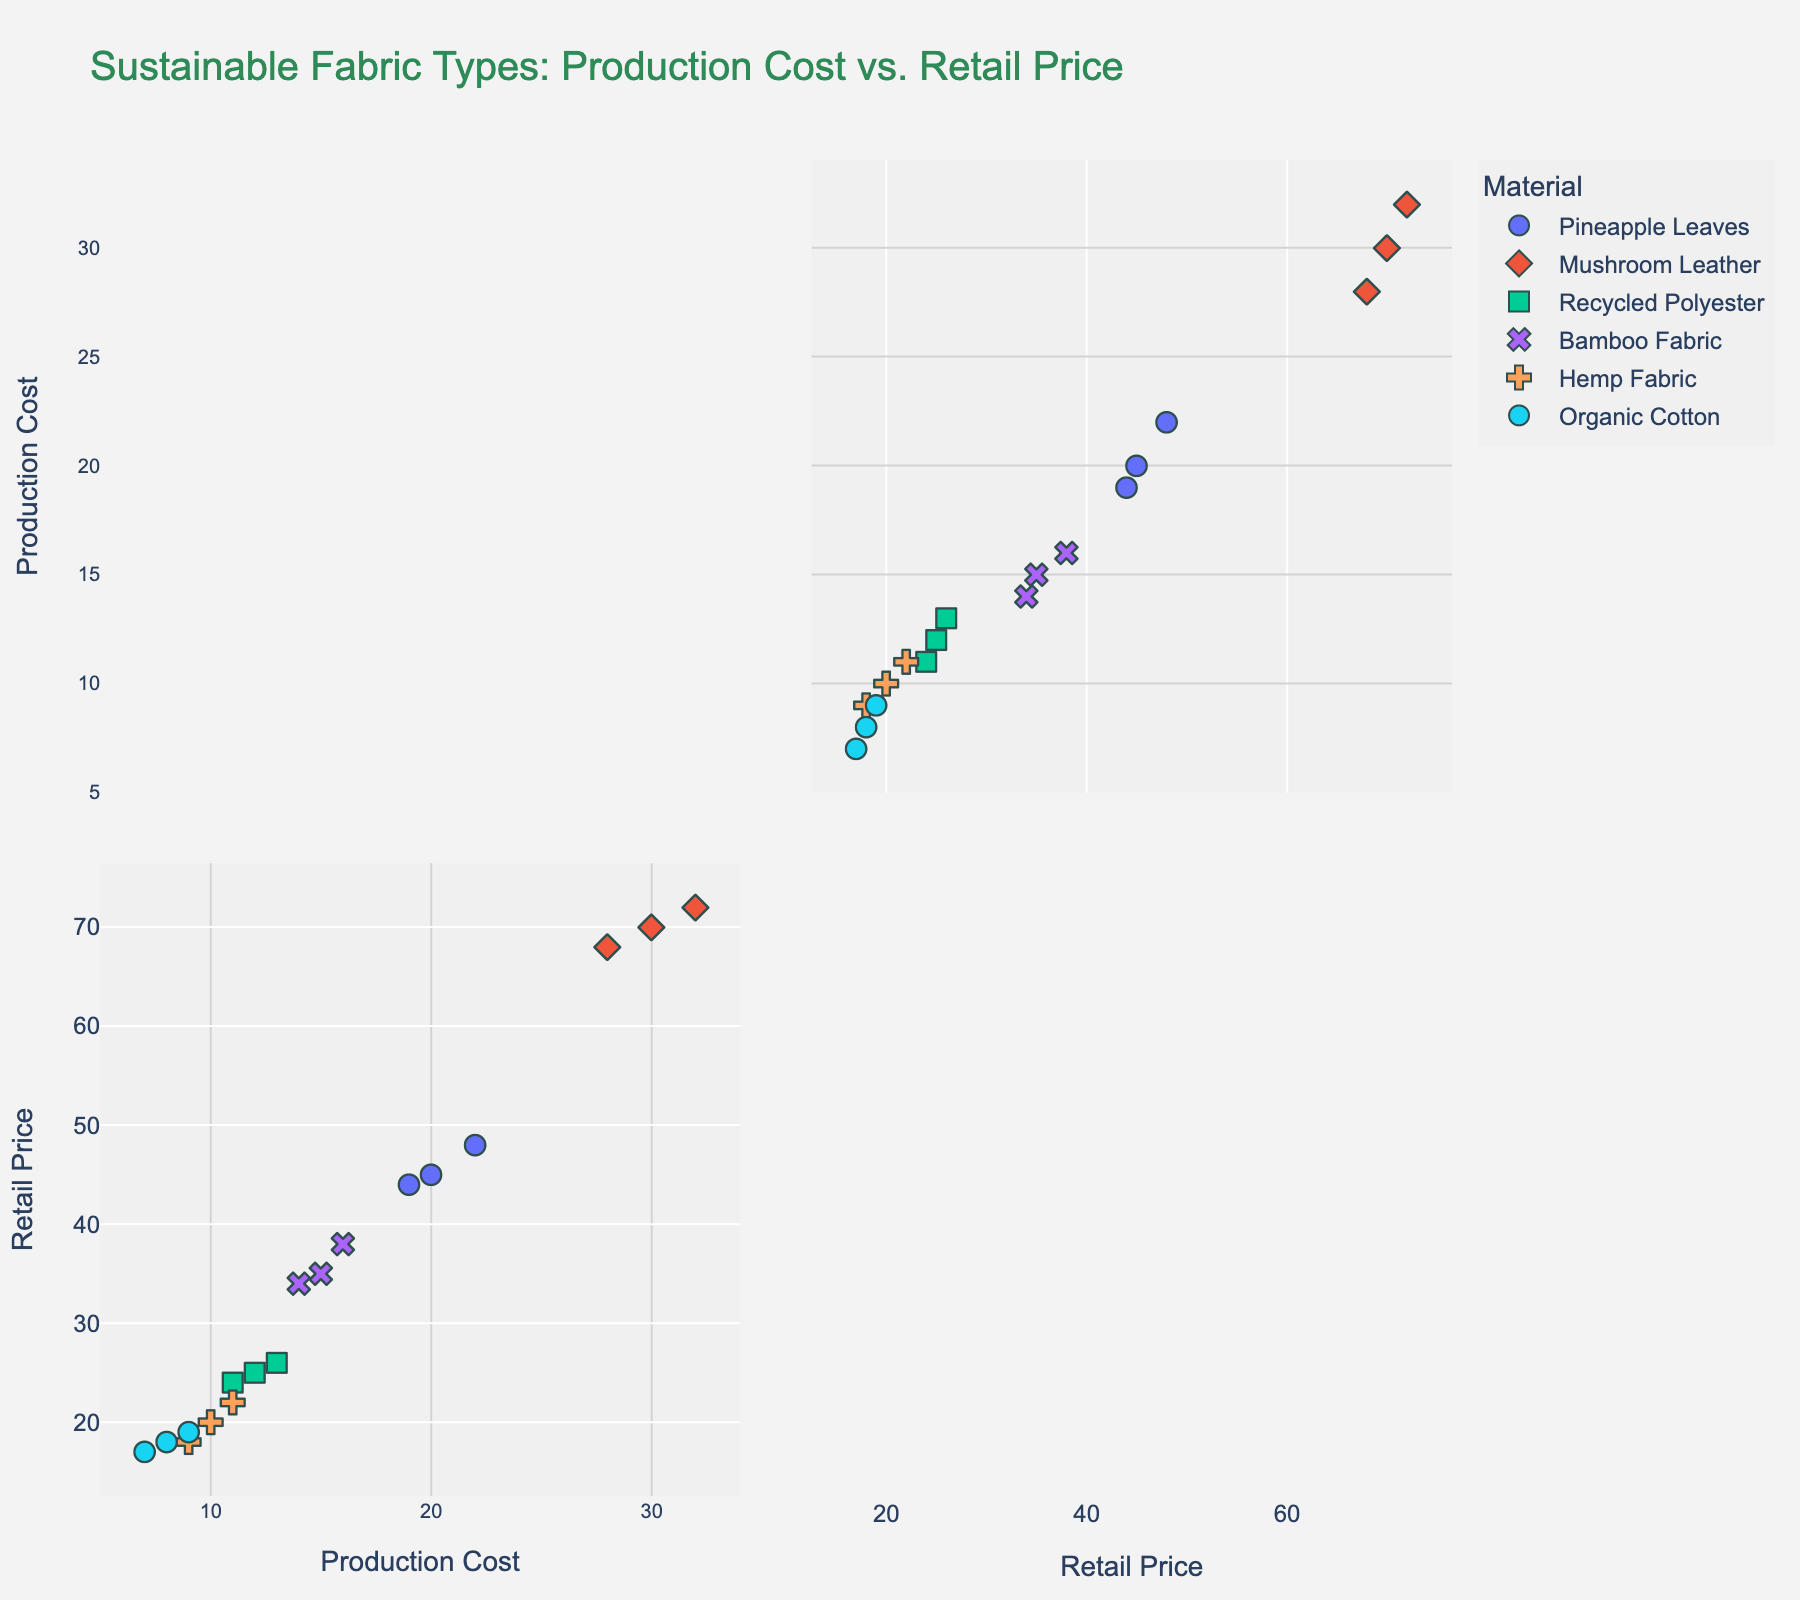What is the title of the scatter plot matrix? The title is often prominently displayed at the top of the figure. It provides a brief summary of what the figure represents.
Answer: Sustainable Fabric Types: Production Cost vs. Retail Price How many different fabric types are represented in the scatter plot matrix? Visual markers like colors and symbols represent different fabric types. Count them to find the number of fabric types.
Answer: 6 What color is used to represent 'Hemp Fabric' in the scatter plot matrix? Different fabric types are represented using various colors. Locate 'Hemp Fabric' in the legend and note its associated color.
Answer: (depends on the figure's color scheme) Which fabric type has the most data points near the bottom left corner of the scatter plot matrix? The bottom left corner represents low production cost and low retail price. Identify the color and symbol located mostly in that area.
Answer: Organic Cotton Which fabric type shows the highest retail price on the scatter plot matrix? To find this, locate the highest point along the retail price axis and check which color and symbol represent that data point.
Answer: Mushroom Leather What is the average production cost of 'Bamboo Fabric'? Identify the data points for 'Bamboo Fabric' and calculate the mean of their production costs: (15 + 16 + 14) / 3.
Answer: 15 Which fabric type has the largest range in retail price? To determine this, find the maximum and minimum retail price for each fabric type, then calculate the range (max - min) for each and compare them.
Answer: Mushroom Leather Between 'Recycled Polyester' and 'Pineapple Leaves', which one has a higher average retail price? Calculate the average retail price for both: Recycled Polyester's average is (25 + 24 + 26) / 3, Pineapple Leaves' average is (45 + 48 + 44) / 3, then compare the two averages.
Answer: Pineapple Leaves Is there a visible correlation between production cost and retail price in 'Mushroom Leather'? Correlation can be observed by the pattern of the points: if they trend upwards together, there is a positive correlation. Examine the scatter plot for Mushroom Leather's trend.
Answer: Yes, positive correlation 